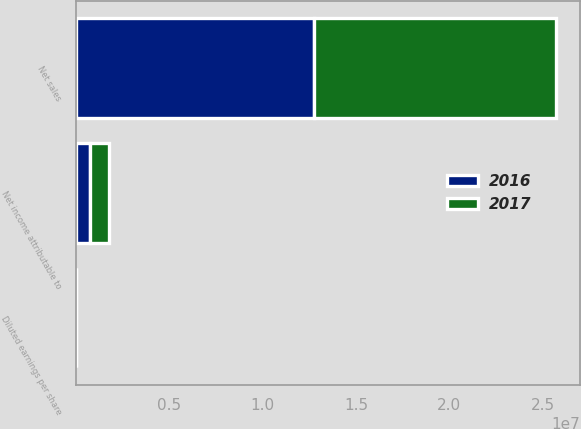Convert chart to OTSL. <chart><loc_0><loc_0><loc_500><loc_500><stacked_bar_chart><ecel><fcel>Net sales<fcel>Net income attributable to<fcel>Diluted earnings per share<nl><fcel>2017<fcel>1.29358e+07<fcel>1.02769e+06<fcel>7.58<nl><fcel>2016<fcel>1.27721e+07<fcel>748634<fcel>5.47<nl></chart> 